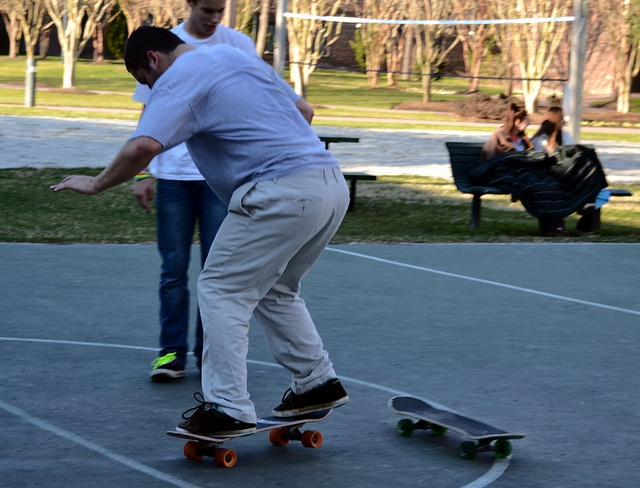Describe the objects in this image and their specific colors. I can see people in tan and gray tones, people in tan, black, lightblue, navy, and gray tones, skateboard in tan, black, gray, blue, and navy tones, skateboard in tan, black, navy, darkblue, and gray tones, and bench in tan, black, gray, darkblue, and blue tones in this image. 